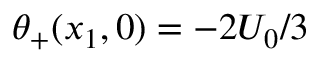Convert formula to latex. <formula><loc_0><loc_0><loc_500><loc_500>\theta _ { + } ( x _ { 1 } , 0 ) = - 2 U _ { 0 } / 3</formula> 